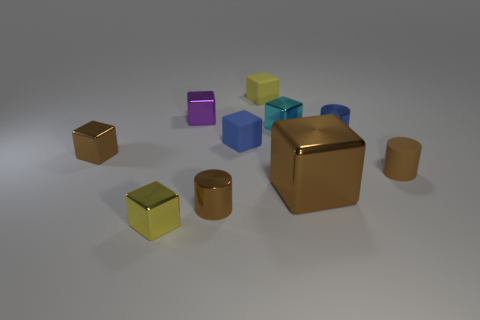There is a tiny matte thing that is the same color as the large shiny thing; what is its shape?
Offer a very short reply. Cylinder. Is the big block the same color as the rubber cylinder?
Make the answer very short. Yes. How many things are either things that are behind the small blue metallic cylinder or small blocks?
Keep it short and to the point. 6. Are there fewer purple metal blocks behind the big shiny cube than small brown objects that are on the right side of the tiny yellow metal object?
Offer a very short reply. Yes. What number of other things are there of the same size as the cyan shiny thing?
Your answer should be very brief. 8. Is the small brown block made of the same material as the yellow cube in front of the brown shiny cylinder?
Your answer should be very brief. Yes. What number of objects are either tiny brown cylinders that are behind the large brown metallic cube or objects in front of the tiny purple thing?
Provide a succinct answer. 8. Is the number of small brown metal cylinders that are in front of the small yellow metallic block less than the number of large blue metal cylinders?
Give a very brief answer. No. Are any purple rubber cubes visible?
Your response must be concise. No. Is the number of brown shiny blocks less than the number of brown things?
Give a very brief answer. Yes. 